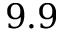Convert formula to latex. <formula><loc_0><loc_0><loc_500><loc_500>9 . 9</formula> 